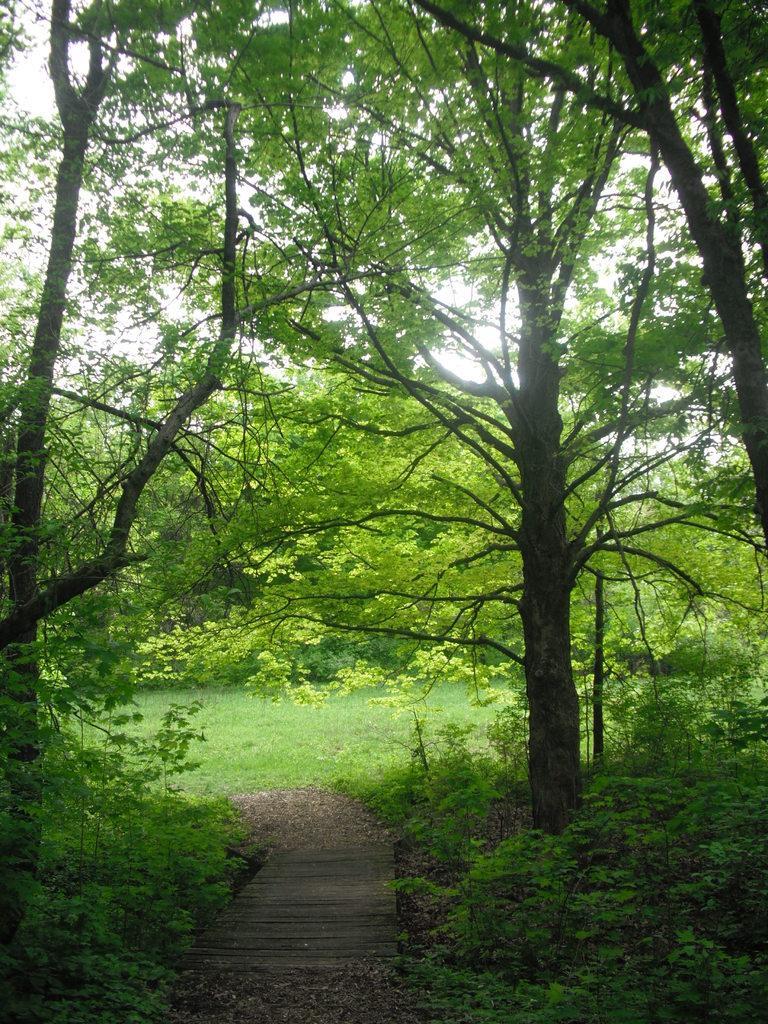In one or two sentences, can you explain what this image depicts? In this picture we can see a wooden path, grass, plants, trees and the sky. 